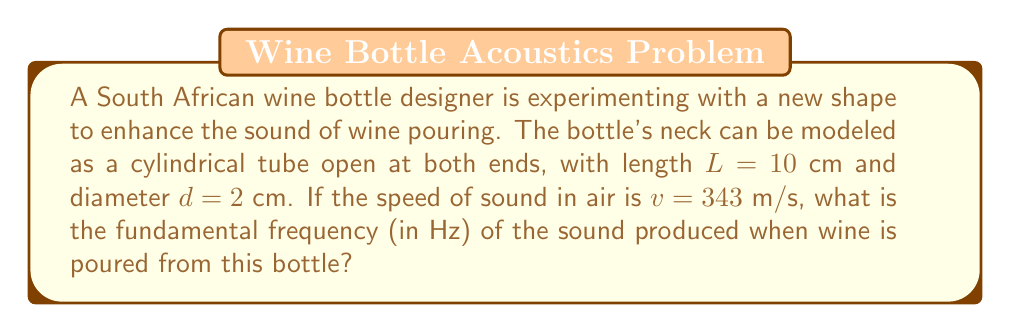Help me with this question. To solve this problem, we'll use the wave equation for a cylindrical tube open at both ends:

1) The formula for the fundamental frequency of a tube open at both ends is:

   $$f = \frac{v}{2L}$$

   Where:
   $f$ = fundamental frequency (Hz)
   $v$ = speed of sound in air (m/s)
   $L$ = length of the tube (m)

2) We're given:
   $v = 343$ m/s
   $L = 10$ cm = $0.1$ m

3) Substituting these values into the equation:

   $$f = \frac{343}{2(0.1)}$$

4) Simplifying:

   $$f = \frac{343}{0.2} = 1715$$

5) Therefore, the fundamental frequency is 1715 Hz.

Note: The diameter of the tube doesn't affect the fundamental frequency in this idealized model, but it would have an effect on the timbre and volume of the sound in a real-world scenario.
Answer: 1715 Hz 